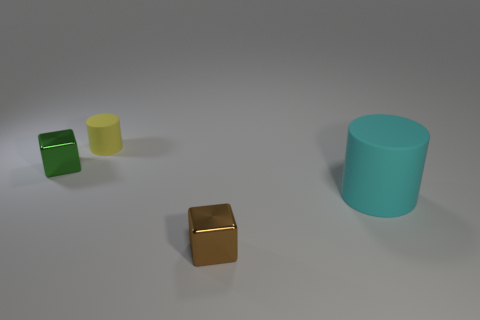Are there any other things that are the same color as the large cylinder?
Offer a terse response. No. Is the size of the brown thing the same as the green metal thing?
Provide a short and direct response. Yes. How many objects are either tiny metallic blocks that are behind the cyan object or tiny metal objects that are behind the tiny brown shiny object?
Provide a short and direct response. 1. The green thing behind the tiny cube in front of the cyan matte thing is made of what material?
Provide a short and direct response. Metal. What number of other things are made of the same material as the small yellow thing?
Make the answer very short. 1. Is the shape of the brown shiny thing the same as the tiny yellow object?
Your answer should be very brief. No. What is the size of the cube behind the brown object?
Offer a terse response. Small. There is a yellow cylinder; is it the same size as the metallic object that is in front of the big cyan rubber object?
Make the answer very short. Yes. Are there fewer large matte objects that are behind the big matte thing than big gray cylinders?
Your answer should be compact. No. What material is the brown thing that is the same shape as the green metal thing?
Provide a succinct answer. Metal. 